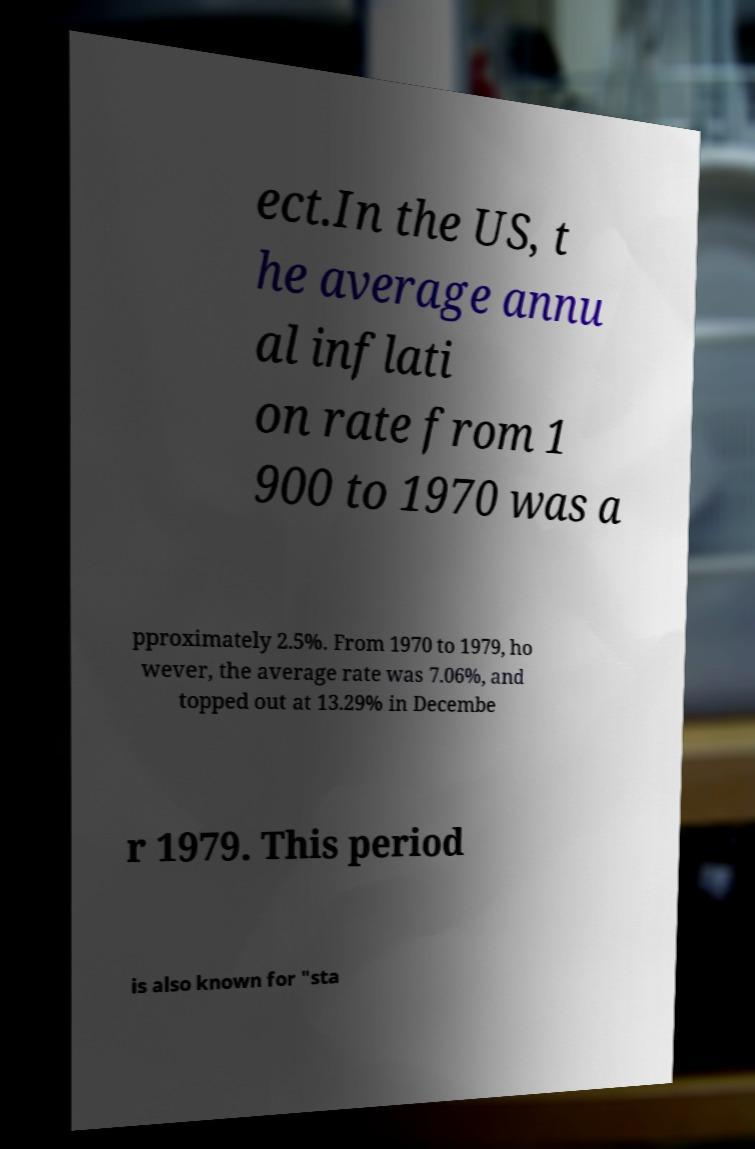Could you assist in decoding the text presented in this image and type it out clearly? ect.In the US, t he average annu al inflati on rate from 1 900 to 1970 was a pproximately 2.5%. From 1970 to 1979, ho wever, the average rate was 7.06%, and topped out at 13.29% in Decembe r 1979. This period is also known for "sta 